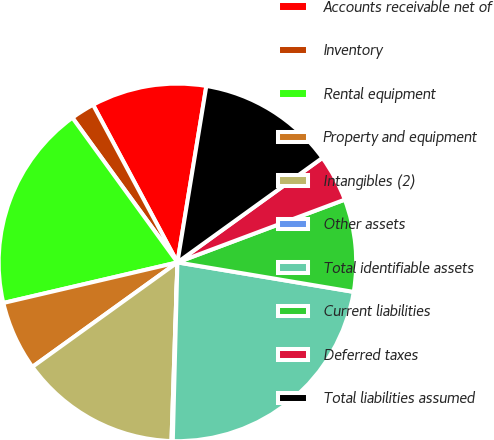<chart> <loc_0><loc_0><loc_500><loc_500><pie_chart><fcel>Accounts receivable net of<fcel>Inventory<fcel>Rental equipment<fcel>Property and equipment<fcel>Intangibles (2)<fcel>Other assets<fcel>Total identifiable assets<fcel>Current liabilities<fcel>Deferred taxes<fcel>Total liabilities assumed<nl><fcel>10.41%<fcel>2.17%<fcel>18.65%<fcel>6.29%<fcel>14.53%<fcel>0.12%<fcel>22.77%<fcel>8.35%<fcel>4.23%<fcel>12.47%<nl></chart> 